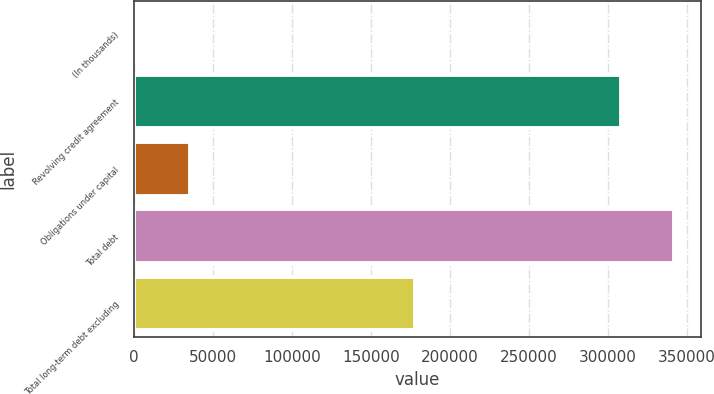Convert chart. <chart><loc_0><loc_0><loc_500><loc_500><bar_chart><fcel>(In thousands)<fcel>Revolving credit agreement<fcel>Obligations under capital<fcel>Total debt<fcel>Total long-term debt excluding<nl><fcel>2009<fcel>308478<fcel>35512.8<fcel>341982<fcel>178062<nl></chart> 